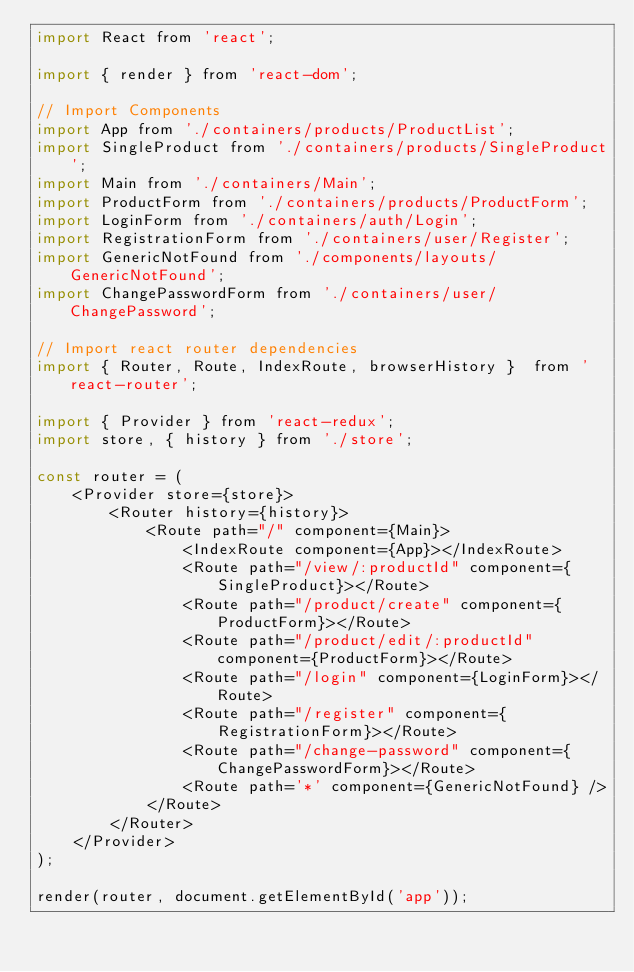Convert code to text. <code><loc_0><loc_0><loc_500><loc_500><_JavaScript_>import React from 'react';

import { render } from 'react-dom';

// Import Components
import App from './containers/products/ProductList';
import SingleProduct from './containers/products/SingleProduct';
import Main from './containers/Main';
import ProductForm from './containers/products/ProductForm';
import LoginForm from './containers/auth/Login';
import RegistrationForm from './containers/user/Register';
import GenericNotFound from './components/layouts/GenericNotFound';
import ChangePasswordForm from './containers/user/ChangePassword';

// Import react router dependencies
import { Router, Route, IndexRoute, browserHistory }  from 'react-router';

import { Provider } from 'react-redux';
import store, { history } from './store';

const router = (
    <Provider store={store}>
        <Router history={history}>
            <Route path="/" component={Main}>
                <IndexRoute component={App}></IndexRoute>
                <Route path="/view/:productId" component={SingleProduct}></Route>
                <Route path="/product/create" component={ProductForm}></Route>
                <Route path="/product/edit/:productId" component={ProductForm}></Route>
                <Route path="/login" component={LoginForm}></Route>
                <Route path="/register" component={RegistrationForm}></Route>
                <Route path="/change-password" component={ChangePasswordForm}></Route>
                <Route path='*' component={GenericNotFound} />
            </Route>
        </Router>
    </Provider>
);

render(router, document.getElementById('app'));</code> 